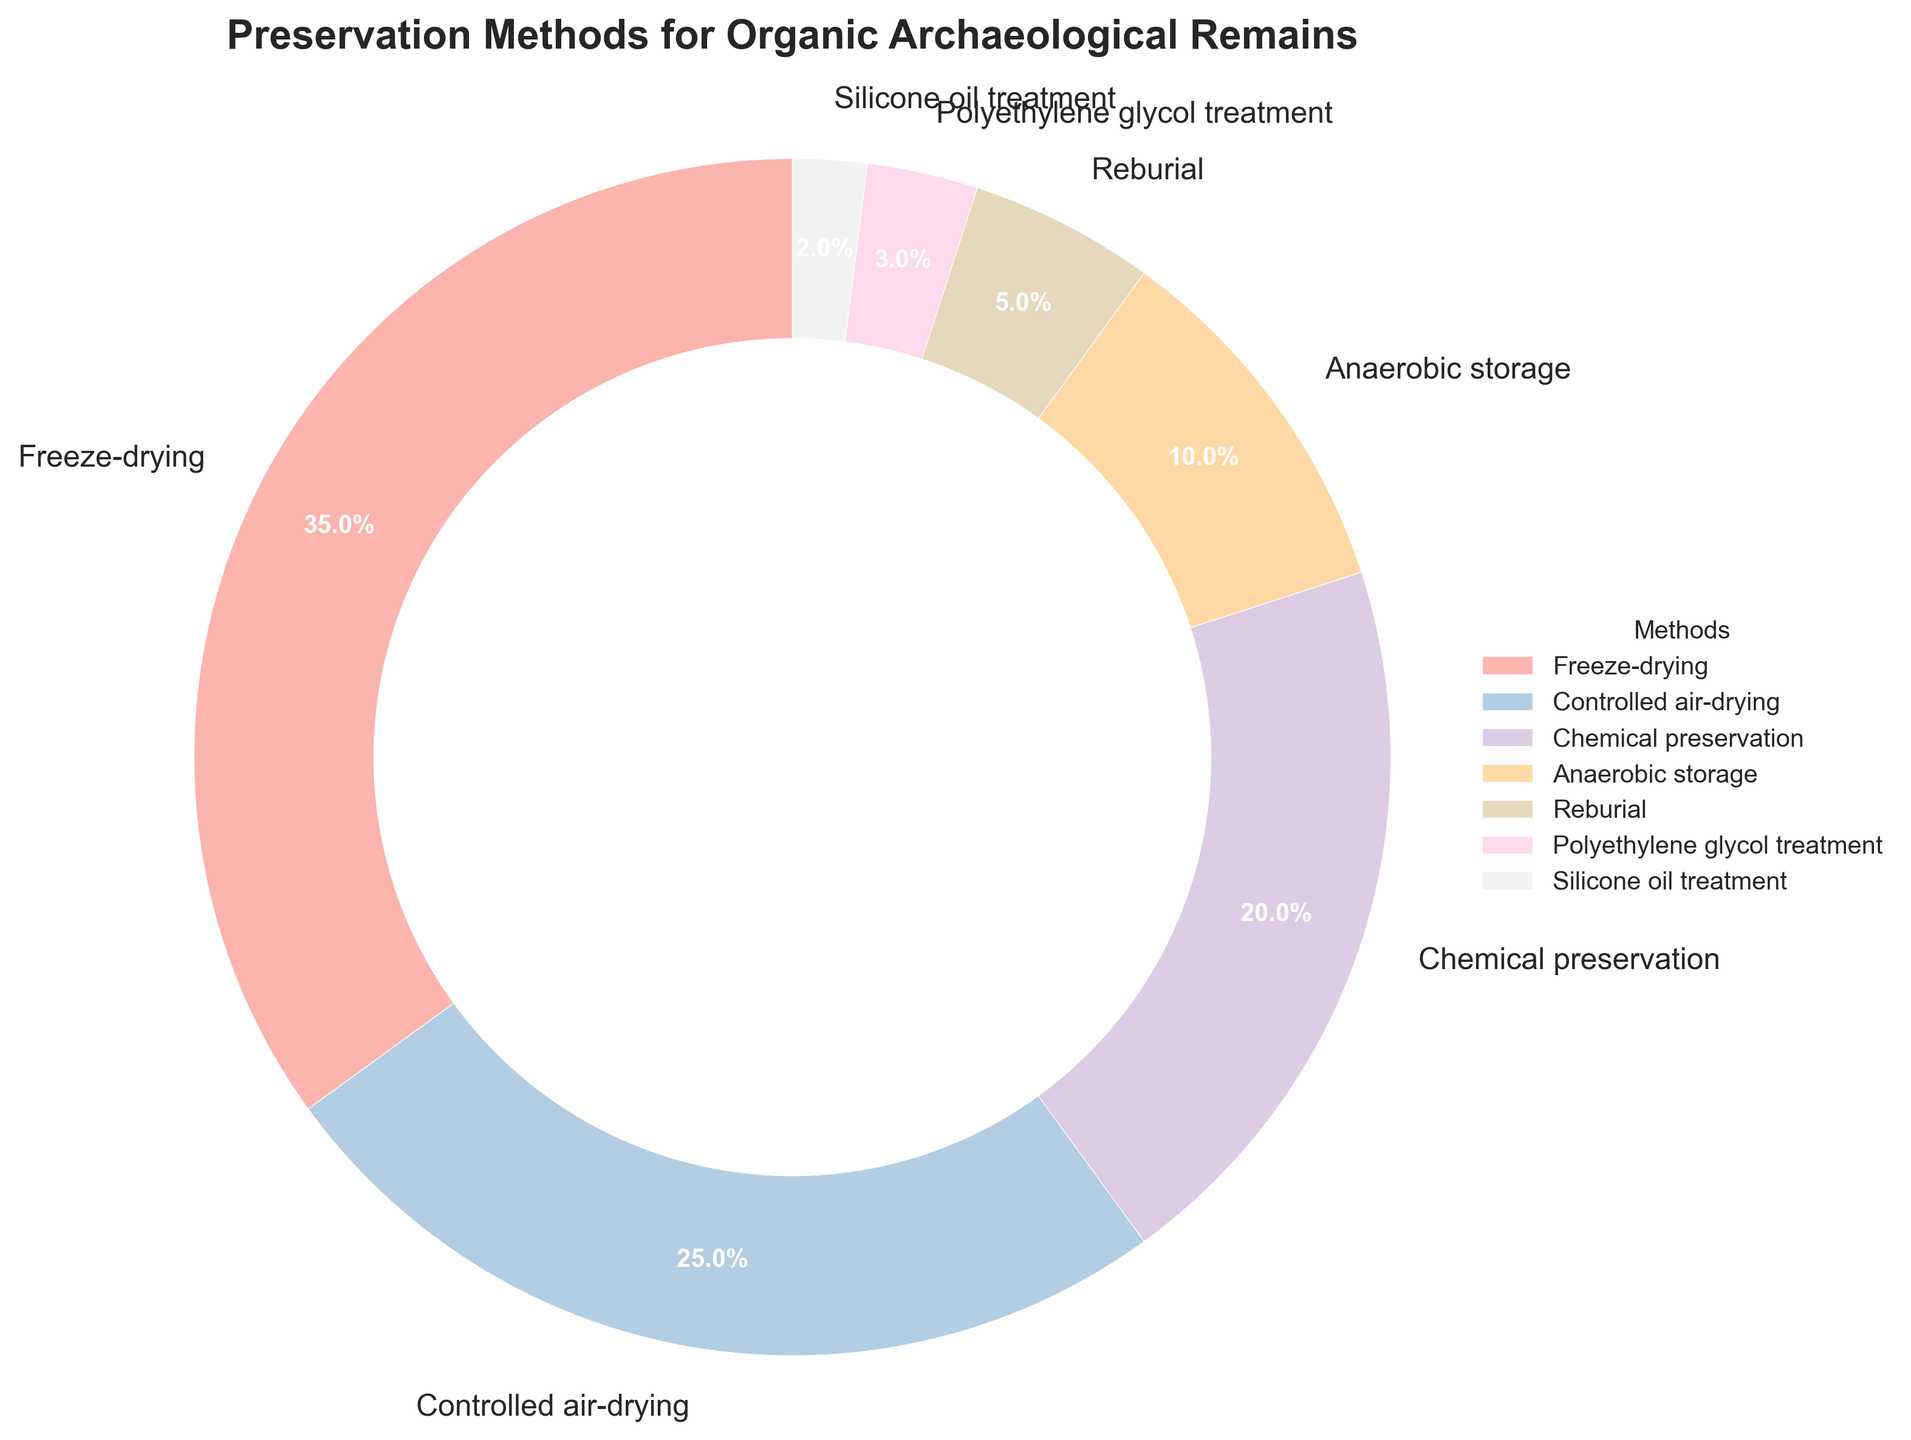Which preservation method is used the most? By looking at the pie chart’s proportions, the section labeled "Freeze-drying" has the largest size, indicating it is used the most.
Answer: Freeze-drying How many preservation methods have a percentage greater than 10%? Observing the pie chart, the sections labeled "Freeze-drying", "Controlled air-drying", and "Chemical preservation" all have percentages greater than 10%.
Answer: 3 What is the combined percentage of Chemical preservation and Anaerobic storage? The percentage for Chemical preservation is 20% and for Anaerobic storage is 10%, adding these together gives 20% + 10% = 30%.
Answer: 30% By how much does Freeze-drying exceed Reburial in percentage? Freeze-drying is at 35% and Reburial is at 5%. The difference is 35% - 5% = 30%.
Answer: 30% Which preservation methods combined account for exactly half of the total percentage? By adding percentages, 35% (Freeze-drying) + 15% (Controlled air-drying and Chemical preservation) gives a total of 60%, overshooting the 50% mark. The closest accurate combination is 35% (Freeze-drying) + 15% (10% Anaerobic storage + 5% Reburial), but the most precise single method close to half is Freeze-drying at 35%. However, this method alone is not half but considering total comprehensively, no exact fraction exists.
Answer: Not exactly possible Are there more preservation methods with percentages below or above 20%? By observing, below 20% are Controlled air-drying (25%), Chemical preservation (20%), Anaerobic storage (10%), Reburial (5%), Polyethylene glycol treatment (3%), and Silicone oil treatment (2%). Above is Freeze-drying alone (35%). Count and compare.
Answer: Below Which preservation method is represented with the smallest section in the chart? By visual observation, the smallest section is labeled "Silicone oil treatment" with 2%.
Answer: Silicone oil treatment What is the visual style used for this pie chart? The pie chart employs the 'seaborn-v0_8' style, pastel colors for sections, and a title at the top.
Answer: Seaborn style If the sections represented 1000 samples, how many samples are associated with Polyethylene glycol treatment? Considering Polyethylene glycol treatment is 3%, calculate 3% of 1000 which is (1000 * 0.03) = 30 samples.
Answer: 30 samples 